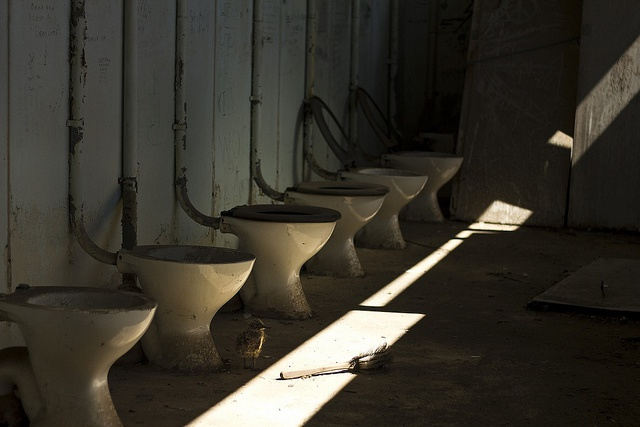Describe the objects in this image and their specific colors. I can see toilet in black and gray tones, toilet in black, gray, and tan tones, toilet in black, gray, and tan tones, toilet in black and gray tones, and toilet in black and gray tones in this image. 